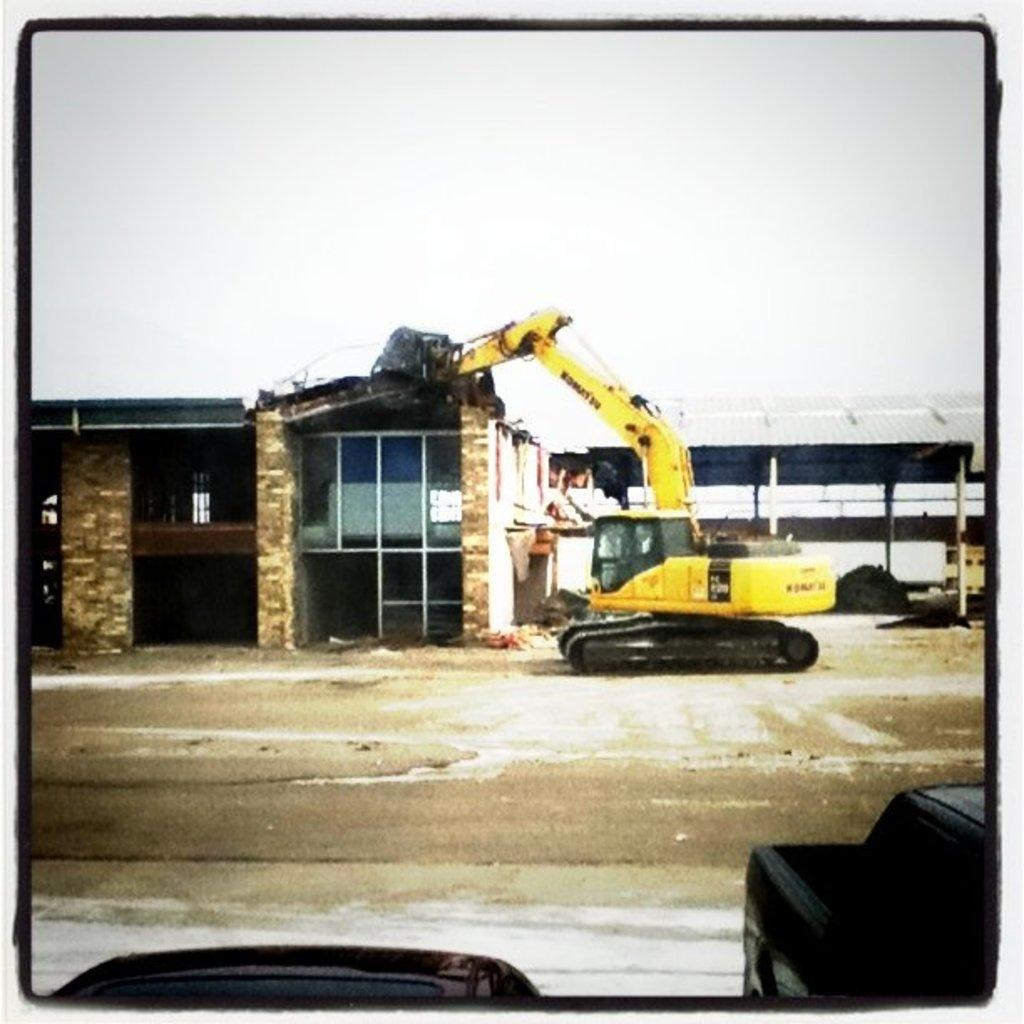What is the main subject of the image? The main subject of the image is an excavator. Where is the excavator located in relation to the building? The excavator is in front of a building. What can be seen at the top of the image? The sky is visible at the top of the image. Can you see a ship sailing in the sky in the image? No, there is no ship sailing in the sky in the image. 